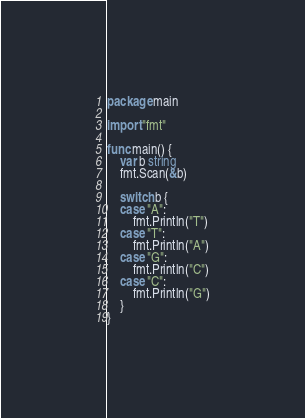Convert code to text. <code><loc_0><loc_0><loc_500><loc_500><_Go_>package main

import "fmt"

func main() {
	var b string
	fmt.Scan(&b)

	switch b {
	case "A":
		fmt.Println("T")
	case "T":
		fmt.Println("A")
	case "G":
		fmt.Println("C")
	case "C":
		fmt.Println("G")
	}
}
</code> 